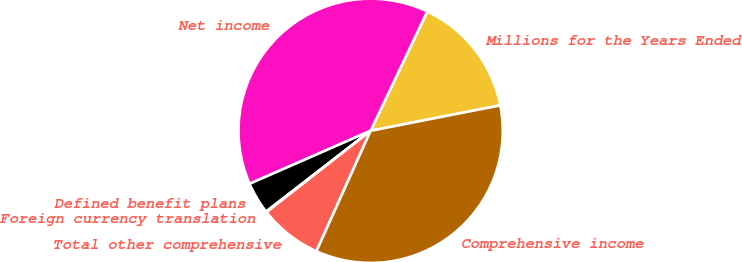Convert chart to OTSL. <chart><loc_0><loc_0><loc_500><loc_500><pie_chart><fcel>Millions for the Years Ended<fcel>Net income<fcel>Defined benefit plans<fcel>Foreign currency translation<fcel>Total other comprehensive<fcel>Comprehensive income<nl><fcel>14.86%<fcel>38.63%<fcel>3.9%<fcel>0.09%<fcel>7.71%<fcel>34.82%<nl></chart> 